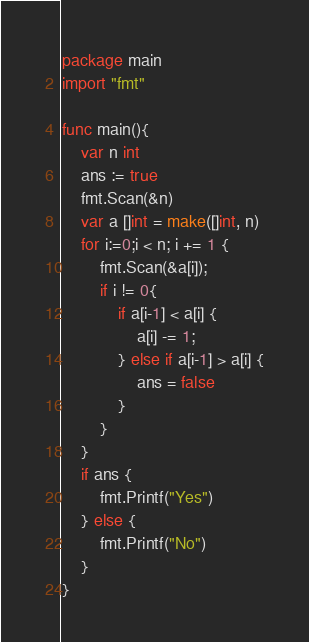<code> <loc_0><loc_0><loc_500><loc_500><_Go_>package main
import "fmt"

func main(){
	var n int
	ans := true
	fmt.Scan(&n)
	var a []int = make([]int, n)
	for i:=0;i < n; i += 1 {
		fmt.Scan(&a[i]);
		if i != 0{
			if a[i-1] < a[i] {
				a[i] -= 1;
			} else if a[i-1] > a[i] {
				ans = false
			}
		}
	}
	if ans {
		fmt.Printf("Yes")
	} else {
		fmt.Printf("No")
	}
}
</code> 